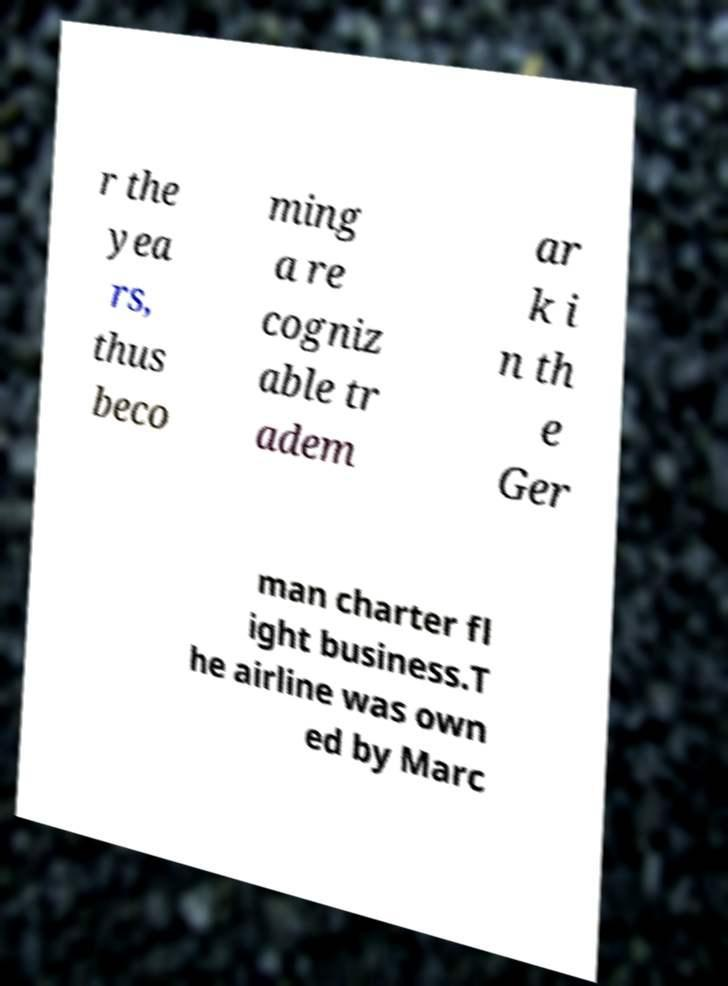I need the written content from this picture converted into text. Can you do that? r the yea rs, thus beco ming a re cogniz able tr adem ar k i n th e Ger man charter fl ight business.T he airline was own ed by Marc 